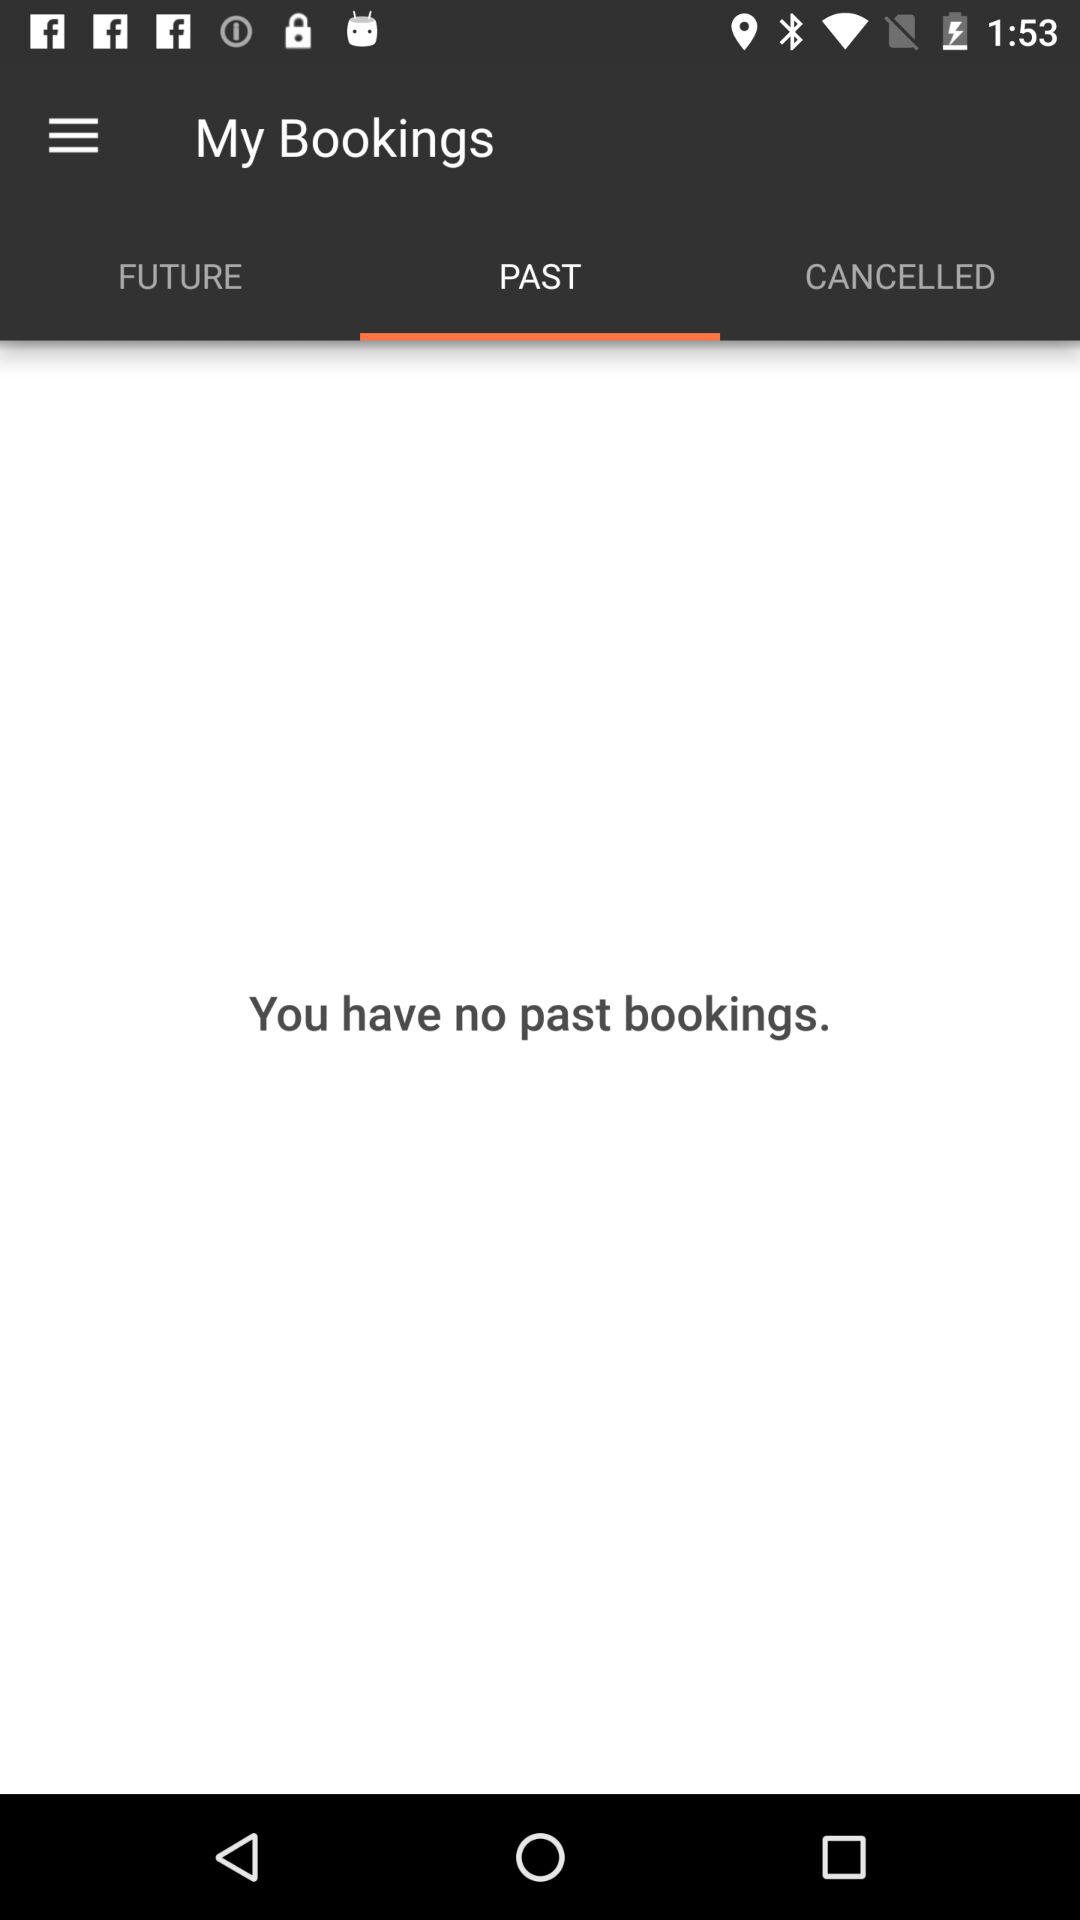Which tab am I on? You are on the "PAST" tab. 